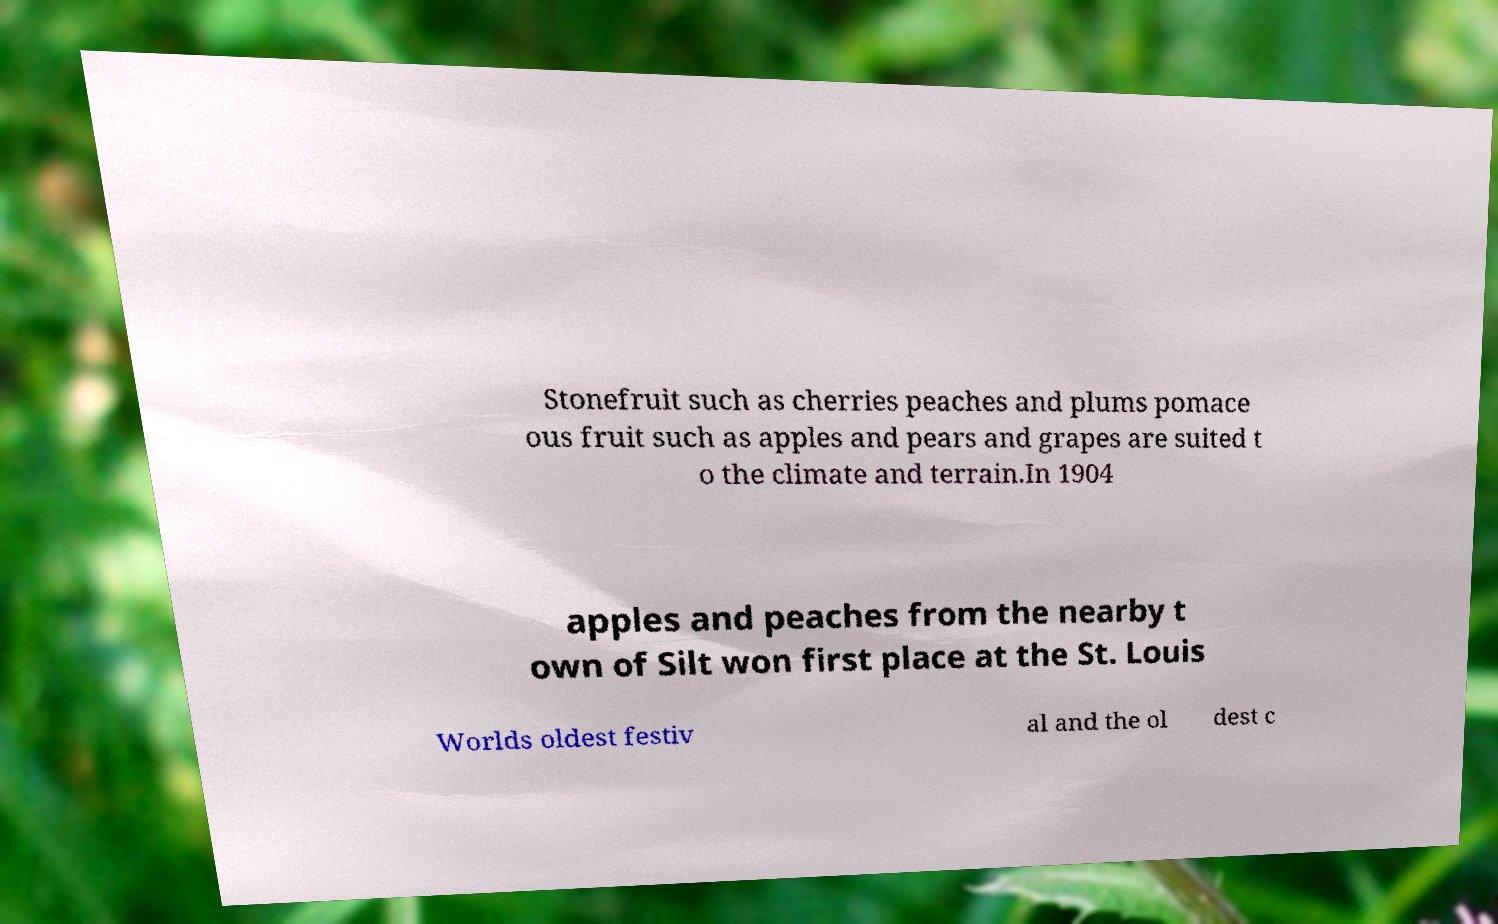Please read and relay the text visible in this image. What does it say? Stonefruit such as cherries peaches and plums pomace ous fruit such as apples and pears and grapes are suited t o the climate and terrain.In 1904 apples and peaches from the nearby t own of Silt won first place at the St. Louis Worlds oldest festiv al and the ol dest c 